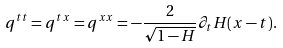<formula> <loc_0><loc_0><loc_500><loc_500>q ^ { t t } = q ^ { t x } = q ^ { x x } = - \frac { 2 } { \sqrt { 1 - H } } \partial _ { t } H ( x - t ) .</formula> 